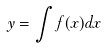<formula> <loc_0><loc_0><loc_500><loc_500>y = \int f ( x ) d x</formula> 